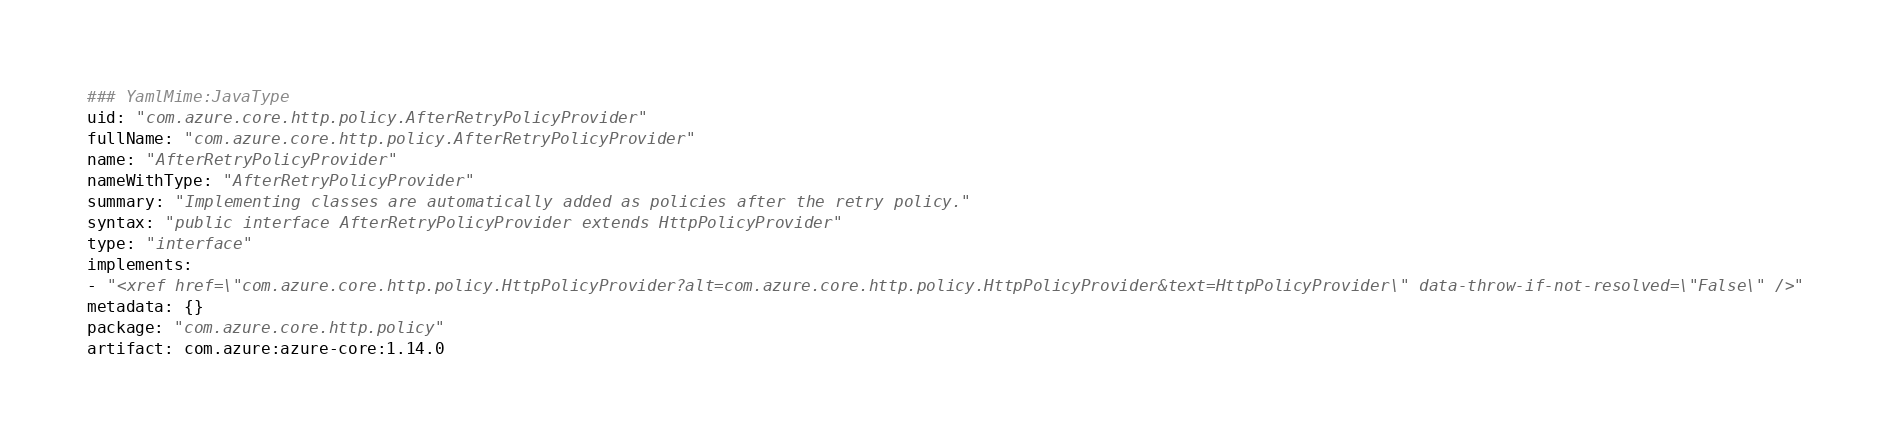<code> <loc_0><loc_0><loc_500><loc_500><_YAML_>### YamlMime:JavaType
uid: "com.azure.core.http.policy.AfterRetryPolicyProvider"
fullName: "com.azure.core.http.policy.AfterRetryPolicyProvider"
name: "AfterRetryPolicyProvider"
nameWithType: "AfterRetryPolicyProvider"
summary: "Implementing classes are automatically added as policies after the retry policy."
syntax: "public interface AfterRetryPolicyProvider extends HttpPolicyProvider"
type: "interface"
implements:
- "<xref href=\"com.azure.core.http.policy.HttpPolicyProvider?alt=com.azure.core.http.policy.HttpPolicyProvider&text=HttpPolicyProvider\" data-throw-if-not-resolved=\"False\" />"
metadata: {}
package: "com.azure.core.http.policy"
artifact: com.azure:azure-core:1.14.0
</code> 